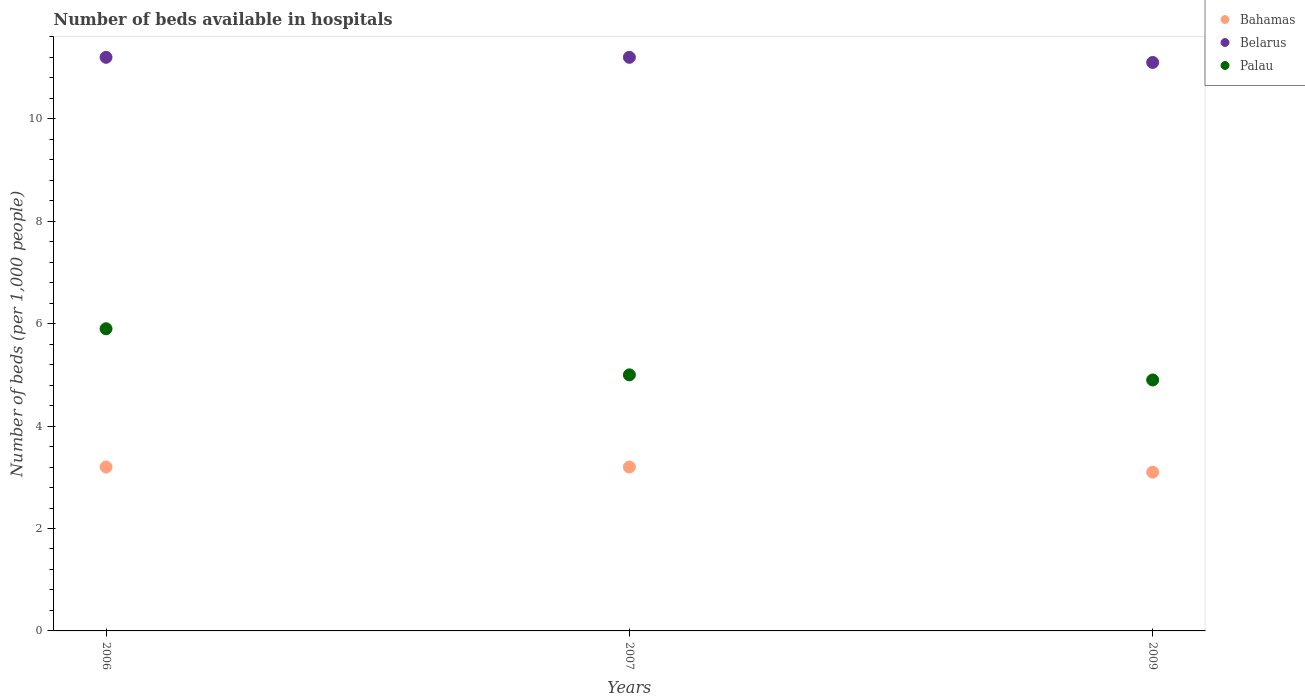What is the number of beds in the hospiatls of in Bahamas in 2006?
Ensure brevity in your answer.  3.2. Across all years, what is the minimum number of beds in the hospiatls of in Palau?
Make the answer very short. 4.9. In which year was the number of beds in the hospiatls of in Palau maximum?
Provide a short and direct response. 2006. What is the average number of beds in the hospiatls of in Belarus per year?
Make the answer very short. 11.17. In the year 2007, what is the difference between the number of beds in the hospiatls of in Belarus and number of beds in the hospiatls of in Bahamas?
Your answer should be very brief. 8. What is the ratio of the number of beds in the hospiatls of in Bahamas in 2006 to that in 2009?
Give a very brief answer. 1.03. Is the difference between the number of beds in the hospiatls of in Belarus in 2007 and 2009 greater than the difference between the number of beds in the hospiatls of in Bahamas in 2007 and 2009?
Your answer should be compact. No. What is the difference between the highest and the lowest number of beds in the hospiatls of in Belarus?
Make the answer very short. 0.1. Is the sum of the number of beds in the hospiatls of in Belarus in 2007 and 2009 greater than the maximum number of beds in the hospiatls of in Bahamas across all years?
Keep it short and to the point. Yes. Is it the case that in every year, the sum of the number of beds in the hospiatls of in Palau and number of beds in the hospiatls of in Belarus  is greater than the number of beds in the hospiatls of in Bahamas?
Keep it short and to the point. Yes. Is the number of beds in the hospiatls of in Belarus strictly greater than the number of beds in the hospiatls of in Palau over the years?
Provide a succinct answer. Yes. Is the number of beds in the hospiatls of in Bahamas strictly less than the number of beds in the hospiatls of in Palau over the years?
Provide a succinct answer. Yes. How many dotlines are there?
Give a very brief answer. 3. What is the difference between two consecutive major ticks on the Y-axis?
Provide a succinct answer. 2. Where does the legend appear in the graph?
Provide a short and direct response. Top right. How many legend labels are there?
Provide a succinct answer. 3. How are the legend labels stacked?
Provide a short and direct response. Vertical. What is the title of the graph?
Make the answer very short. Number of beds available in hospitals. Does "Cuba" appear as one of the legend labels in the graph?
Your answer should be compact. No. What is the label or title of the Y-axis?
Provide a succinct answer. Number of beds (per 1,0 people). What is the Number of beds (per 1,000 people) in Belarus in 2006?
Provide a short and direct response. 11.2. What is the Number of beds (per 1,000 people) in Palau in 2006?
Your response must be concise. 5.9. What is the Number of beds (per 1,000 people) of Bahamas in 2007?
Keep it short and to the point. 3.2. What is the Number of beds (per 1,000 people) of Belarus in 2007?
Offer a very short reply. 11.2. What is the Number of beds (per 1,000 people) of Palau in 2009?
Offer a very short reply. 4.9. Across all years, what is the maximum Number of beds (per 1,000 people) of Bahamas?
Make the answer very short. 3.2. Across all years, what is the maximum Number of beds (per 1,000 people) of Palau?
Your answer should be very brief. 5.9. Across all years, what is the minimum Number of beds (per 1,000 people) in Bahamas?
Ensure brevity in your answer.  3.1. Across all years, what is the minimum Number of beds (per 1,000 people) of Belarus?
Offer a terse response. 11.1. What is the total Number of beds (per 1,000 people) of Bahamas in the graph?
Offer a very short reply. 9.5. What is the total Number of beds (per 1,000 people) of Belarus in the graph?
Your answer should be compact. 33.5. What is the total Number of beds (per 1,000 people) of Palau in the graph?
Your response must be concise. 15.8. What is the difference between the Number of beds (per 1,000 people) in Bahamas in 2006 and that in 2007?
Provide a succinct answer. 0. What is the difference between the Number of beds (per 1,000 people) of Belarus in 2006 and that in 2007?
Your answer should be very brief. 0. What is the difference between the Number of beds (per 1,000 people) in Palau in 2006 and that in 2007?
Offer a very short reply. 0.9. What is the difference between the Number of beds (per 1,000 people) in Bahamas in 2006 and that in 2009?
Your response must be concise. 0.1. What is the difference between the Number of beds (per 1,000 people) of Belarus in 2006 and that in 2009?
Your answer should be very brief. 0.1. What is the difference between the Number of beds (per 1,000 people) in Palau in 2006 and that in 2009?
Offer a terse response. 1. What is the difference between the Number of beds (per 1,000 people) in Belarus in 2007 and that in 2009?
Provide a short and direct response. 0.1. What is the difference between the Number of beds (per 1,000 people) of Bahamas in 2006 and the Number of beds (per 1,000 people) of Palau in 2007?
Your answer should be very brief. -1.8. What is the difference between the Number of beds (per 1,000 people) in Belarus in 2006 and the Number of beds (per 1,000 people) in Palau in 2007?
Make the answer very short. 6.2. What is the difference between the Number of beds (per 1,000 people) in Bahamas in 2006 and the Number of beds (per 1,000 people) in Palau in 2009?
Your answer should be very brief. -1.7. What is the difference between the Number of beds (per 1,000 people) of Bahamas in 2007 and the Number of beds (per 1,000 people) of Palau in 2009?
Your response must be concise. -1.7. What is the difference between the Number of beds (per 1,000 people) in Belarus in 2007 and the Number of beds (per 1,000 people) in Palau in 2009?
Offer a very short reply. 6.3. What is the average Number of beds (per 1,000 people) in Bahamas per year?
Give a very brief answer. 3.17. What is the average Number of beds (per 1,000 people) in Belarus per year?
Your answer should be compact. 11.17. What is the average Number of beds (per 1,000 people) of Palau per year?
Your answer should be compact. 5.27. In the year 2006, what is the difference between the Number of beds (per 1,000 people) of Bahamas and Number of beds (per 1,000 people) of Belarus?
Make the answer very short. -8. In the year 2006, what is the difference between the Number of beds (per 1,000 people) in Bahamas and Number of beds (per 1,000 people) in Palau?
Offer a very short reply. -2.7. In the year 2006, what is the difference between the Number of beds (per 1,000 people) of Belarus and Number of beds (per 1,000 people) of Palau?
Keep it short and to the point. 5.3. In the year 2007, what is the difference between the Number of beds (per 1,000 people) of Bahamas and Number of beds (per 1,000 people) of Belarus?
Your answer should be very brief. -8. What is the ratio of the Number of beds (per 1,000 people) in Bahamas in 2006 to that in 2007?
Your response must be concise. 1. What is the ratio of the Number of beds (per 1,000 people) in Belarus in 2006 to that in 2007?
Make the answer very short. 1. What is the ratio of the Number of beds (per 1,000 people) of Palau in 2006 to that in 2007?
Offer a terse response. 1.18. What is the ratio of the Number of beds (per 1,000 people) in Bahamas in 2006 to that in 2009?
Ensure brevity in your answer.  1.03. What is the ratio of the Number of beds (per 1,000 people) of Palau in 2006 to that in 2009?
Offer a very short reply. 1.2. What is the ratio of the Number of beds (per 1,000 people) of Bahamas in 2007 to that in 2009?
Ensure brevity in your answer.  1.03. What is the ratio of the Number of beds (per 1,000 people) of Belarus in 2007 to that in 2009?
Make the answer very short. 1.01. What is the ratio of the Number of beds (per 1,000 people) of Palau in 2007 to that in 2009?
Make the answer very short. 1.02. What is the difference between the highest and the second highest Number of beds (per 1,000 people) in Belarus?
Your response must be concise. 0. What is the difference between the highest and the lowest Number of beds (per 1,000 people) in Palau?
Provide a succinct answer. 1. 